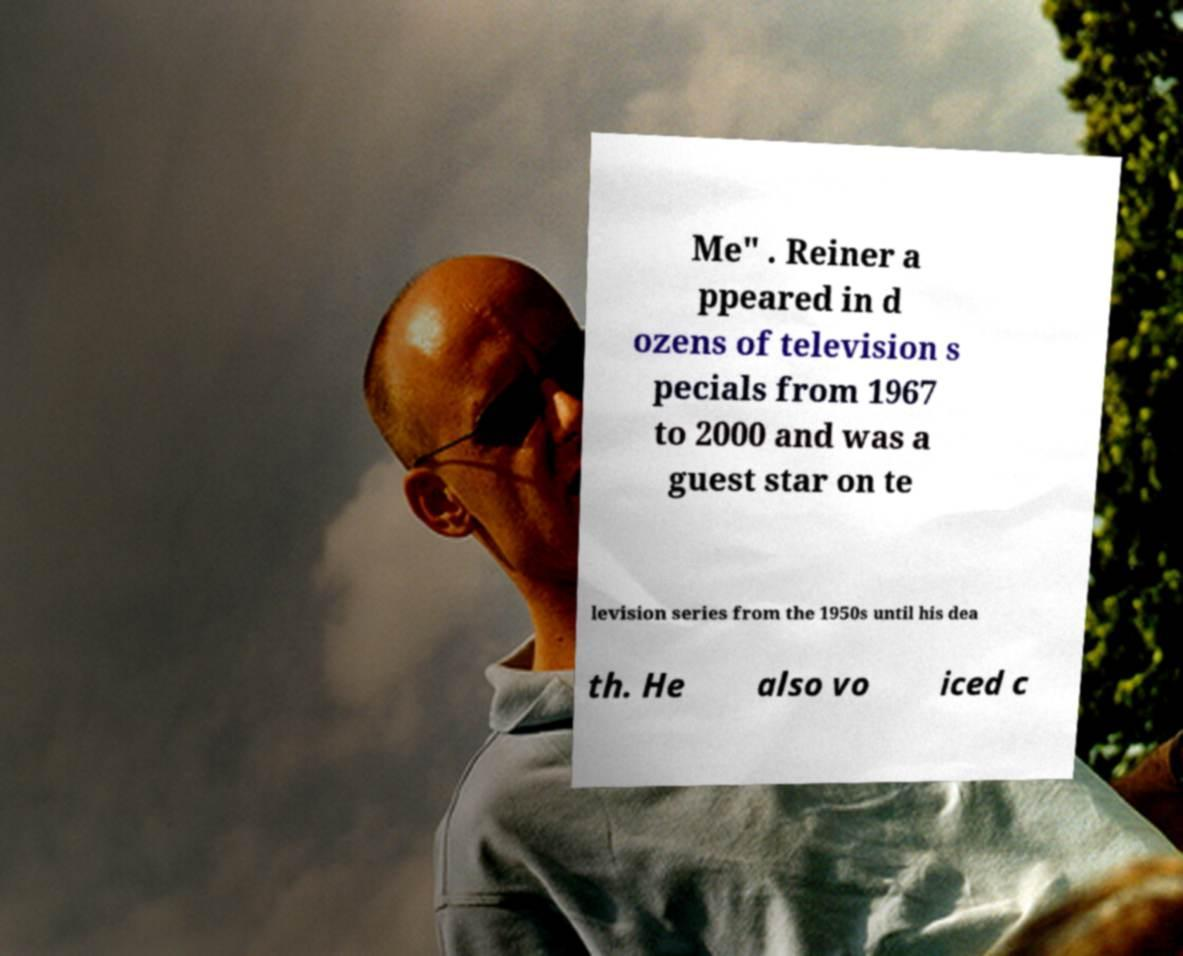Could you assist in decoding the text presented in this image and type it out clearly? Me" . Reiner a ppeared in d ozens of television s pecials from 1967 to 2000 and was a guest star on te levision series from the 1950s until his dea th. He also vo iced c 